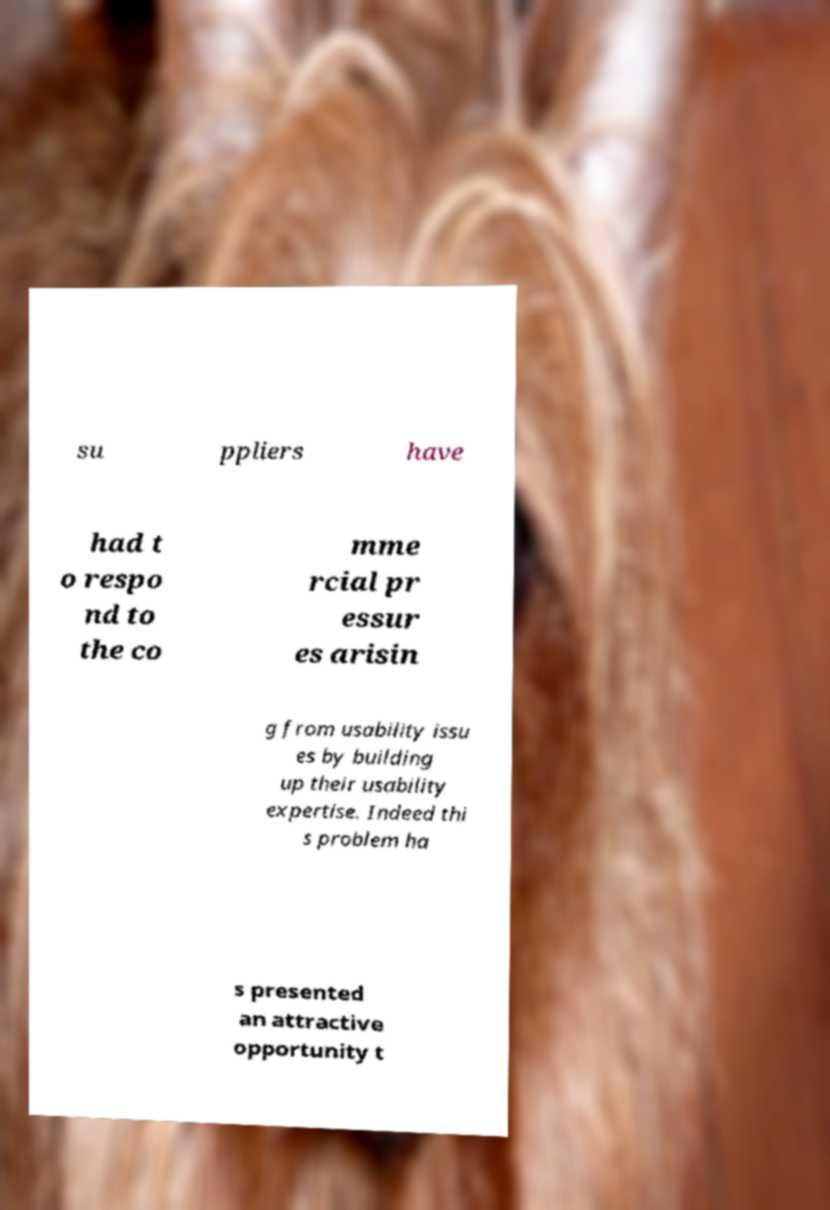Can you read and provide the text displayed in the image?This photo seems to have some interesting text. Can you extract and type it out for me? su ppliers have had t o respo nd to the co mme rcial pr essur es arisin g from usability issu es by building up their usability expertise. Indeed thi s problem ha s presented an attractive opportunity t 